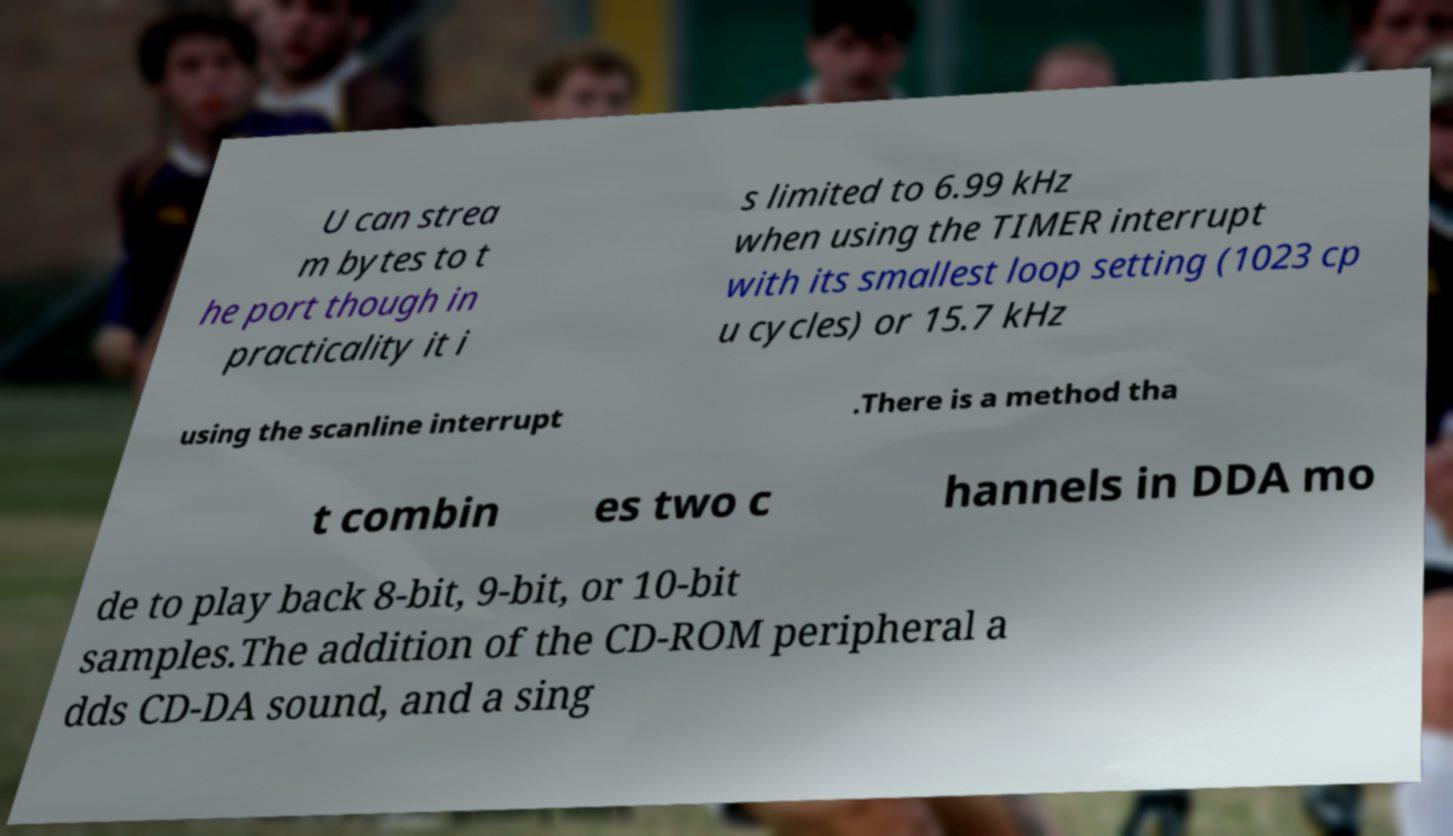Please identify and transcribe the text found in this image. U can strea m bytes to t he port though in practicality it i s limited to 6.99 kHz when using the TIMER interrupt with its smallest loop setting (1023 cp u cycles) or 15.7 kHz using the scanline interrupt .There is a method tha t combin es two c hannels in DDA mo de to play back 8-bit, 9-bit, or 10-bit samples.The addition of the CD-ROM peripheral a dds CD-DA sound, and a sing 